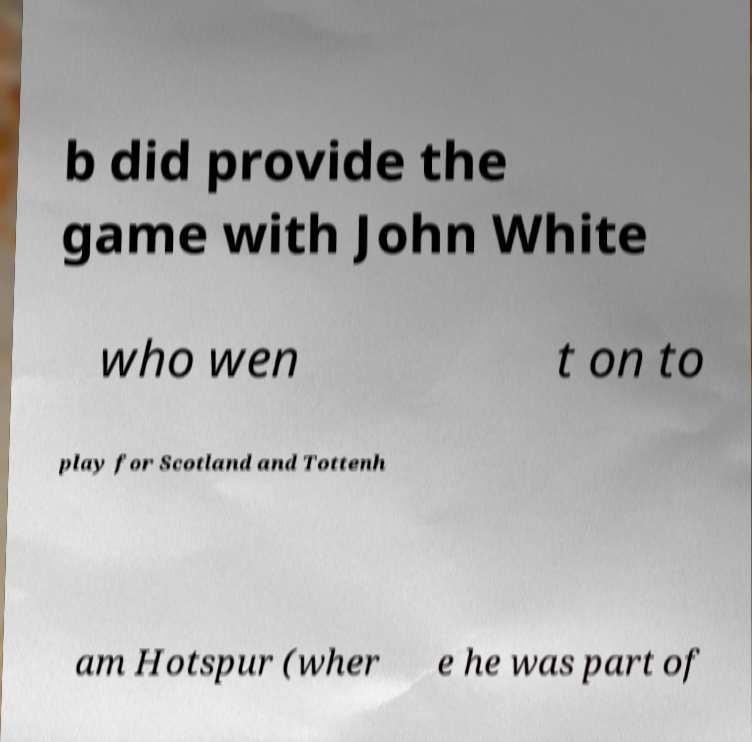Please identify and transcribe the text found in this image. b did provide the game with John White who wen t on to play for Scotland and Tottenh am Hotspur (wher e he was part of 